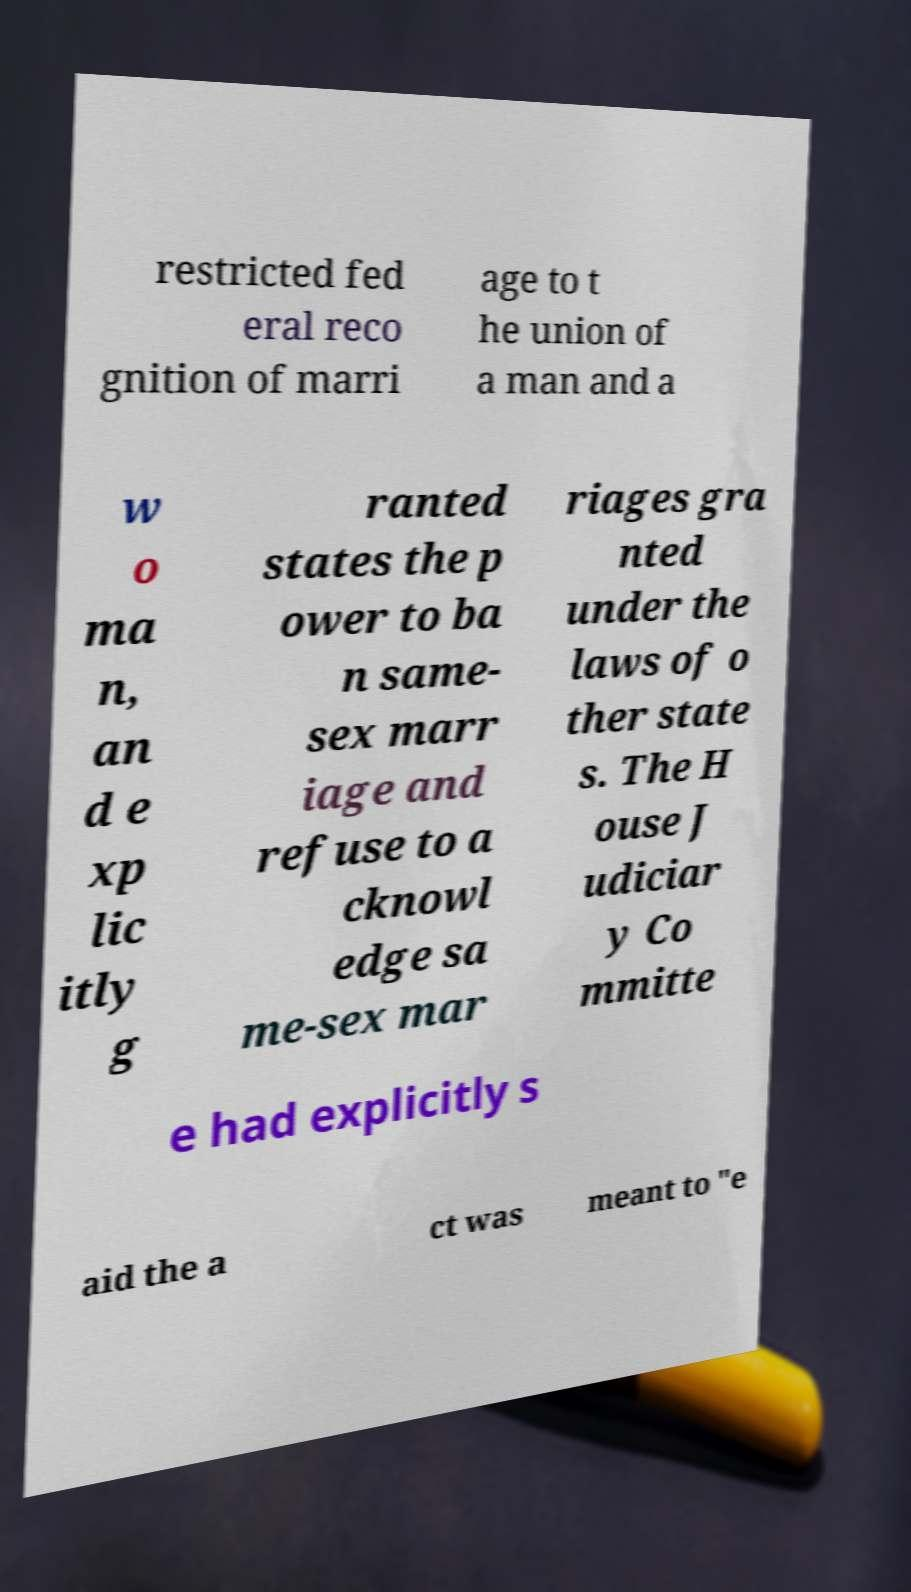Can you read and provide the text displayed in the image?This photo seems to have some interesting text. Can you extract and type it out for me? restricted fed eral reco gnition of marri age to t he union of a man and a w o ma n, an d e xp lic itly g ranted states the p ower to ba n same- sex marr iage and refuse to a cknowl edge sa me-sex mar riages gra nted under the laws of o ther state s. The H ouse J udiciar y Co mmitte e had explicitly s aid the a ct was meant to "e 